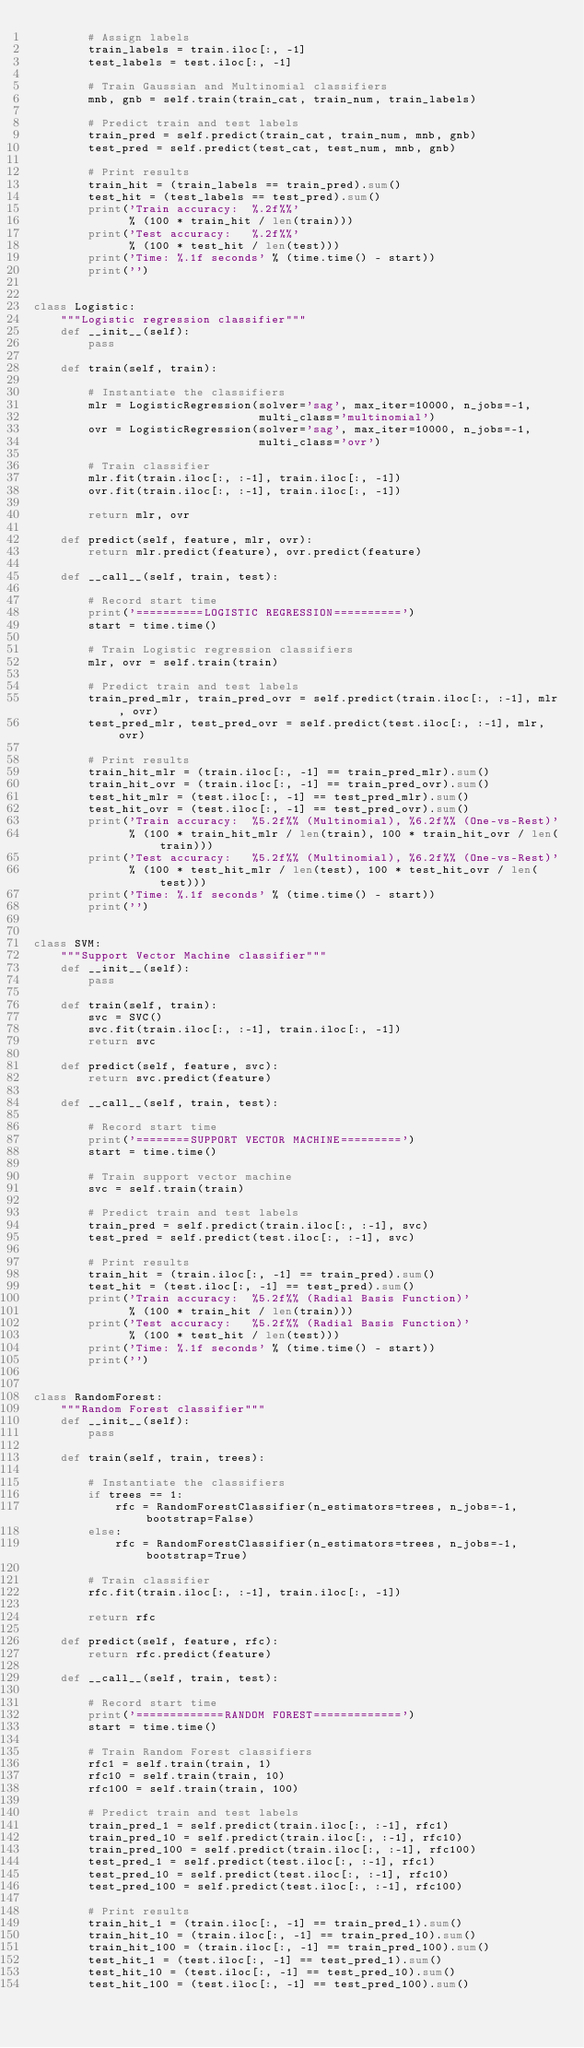Convert code to text. <code><loc_0><loc_0><loc_500><loc_500><_Python_>        # Assign labels
        train_labels = train.iloc[:, -1]
        test_labels = test.iloc[:, -1]

        # Train Gaussian and Multinomial classifiers
        mnb, gnb = self.train(train_cat, train_num, train_labels)

        # Predict train and test labels
        train_pred = self.predict(train_cat, train_num, mnb, gnb)
        test_pred = self.predict(test_cat, test_num, mnb, gnb)

        # Print results
        train_hit = (train_labels == train_pred).sum()
        test_hit = (test_labels == test_pred).sum()
        print('Train accuracy:  %.2f%%'
              % (100 * train_hit / len(train)))
        print('Test accuracy:   %.2f%%'
              % (100 * test_hit / len(test)))
        print('Time: %.1f seconds' % (time.time() - start))
        print('')


class Logistic:
    """Logistic regression classifier"""
    def __init__(self):
        pass

    def train(self, train):

        # Instantiate the classifiers
        mlr = LogisticRegression(solver='sag', max_iter=10000, n_jobs=-1,
                                 multi_class='multinomial')
        ovr = LogisticRegression(solver='sag', max_iter=10000, n_jobs=-1,
                                 multi_class='ovr')

        # Train classifier
        mlr.fit(train.iloc[:, :-1], train.iloc[:, -1])
        ovr.fit(train.iloc[:, :-1], train.iloc[:, -1])

        return mlr, ovr

    def predict(self, feature, mlr, ovr):
        return mlr.predict(feature), ovr.predict(feature)

    def __call__(self, train, test):

        # Record start time
        print('==========LOGISTIC REGRESSION==========')
        start = time.time()

        # Train Logistic regression classifiers
        mlr, ovr = self.train(train)

        # Predict train and test labels
        train_pred_mlr, train_pred_ovr = self.predict(train.iloc[:, :-1], mlr, ovr)
        test_pred_mlr, test_pred_ovr = self.predict(test.iloc[:, :-1], mlr, ovr)

        # Print results
        train_hit_mlr = (train.iloc[:, -1] == train_pred_mlr).sum()
        train_hit_ovr = (train.iloc[:, -1] == train_pred_ovr).sum()
        test_hit_mlr = (test.iloc[:, -1] == test_pred_mlr).sum()
        test_hit_ovr = (test.iloc[:, -1] == test_pred_ovr).sum()
        print('Train accuracy:  %5.2f%% (Multinomial), %6.2f%% (One-vs-Rest)'
              % (100 * train_hit_mlr / len(train), 100 * train_hit_ovr / len(train)))
        print('Test accuracy:   %5.2f%% (Multinomial), %6.2f%% (One-vs-Rest)'
              % (100 * test_hit_mlr / len(test), 100 * test_hit_ovr / len(test)))
        print('Time: %.1f seconds' % (time.time() - start))
        print('')


class SVM:
    """Support Vector Machine classifier"""
    def __init__(self):
        pass

    def train(self, train):
        svc = SVC()
        svc.fit(train.iloc[:, :-1], train.iloc[:, -1])
        return svc

    def predict(self, feature, svc):
        return svc.predict(feature)

    def __call__(self, train, test):

        # Record start time
        print('========SUPPORT VECTOR MACHINE=========')
        start = time.time()

        # Train support vector machine
        svc = self.train(train)

        # Predict train and test labels
        train_pred = self.predict(train.iloc[:, :-1], svc)
        test_pred = self.predict(test.iloc[:, :-1], svc)

        # Print results
        train_hit = (train.iloc[:, -1] == train_pred).sum()
        test_hit = (test.iloc[:, -1] == test_pred).sum()
        print('Train accuracy:  %5.2f%% (Radial Basis Function)'
              % (100 * train_hit / len(train)))
        print('Test accuracy:   %5.2f%% (Radial Basis Function)'
              % (100 * test_hit / len(test)))
        print('Time: %.1f seconds' % (time.time() - start))
        print('')


class RandomForest:
    """Random Forest classifier"""
    def __init__(self):
        pass

    def train(self, train, trees):

        # Instantiate the classifiers
        if trees == 1:
            rfc = RandomForestClassifier(n_estimators=trees, n_jobs=-1, bootstrap=False)
        else:
            rfc = RandomForestClassifier(n_estimators=trees, n_jobs=-1, bootstrap=True)

        # Train classifier
        rfc.fit(train.iloc[:, :-1], train.iloc[:, -1])

        return rfc

    def predict(self, feature, rfc):
        return rfc.predict(feature)

    def __call__(self, train, test):

        # Record start time
        print('=============RANDOM FOREST=============')
        start = time.time()

        # Train Random Forest classifiers
        rfc1 = self.train(train, 1)
        rfc10 = self.train(train, 10)
        rfc100 = self.train(train, 100)

        # Predict train and test labels
        train_pred_1 = self.predict(train.iloc[:, :-1], rfc1)
        train_pred_10 = self.predict(train.iloc[:, :-1], rfc10)
        train_pred_100 = self.predict(train.iloc[:, :-1], rfc100)
        test_pred_1 = self.predict(test.iloc[:, :-1], rfc1)
        test_pred_10 = self.predict(test.iloc[:, :-1], rfc10)
        test_pred_100 = self.predict(test.iloc[:, :-1], rfc100)

        # Print results
        train_hit_1 = (train.iloc[:, -1] == train_pred_1).sum()
        train_hit_10 = (train.iloc[:, -1] == train_pred_10).sum()
        train_hit_100 = (train.iloc[:, -1] == train_pred_100).sum()
        test_hit_1 = (test.iloc[:, -1] == test_pred_1).sum()
        test_hit_10 = (test.iloc[:, -1] == test_pred_10).sum()
        test_hit_100 = (test.iloc[:, -1] == test_pred_100).sum()</code> 